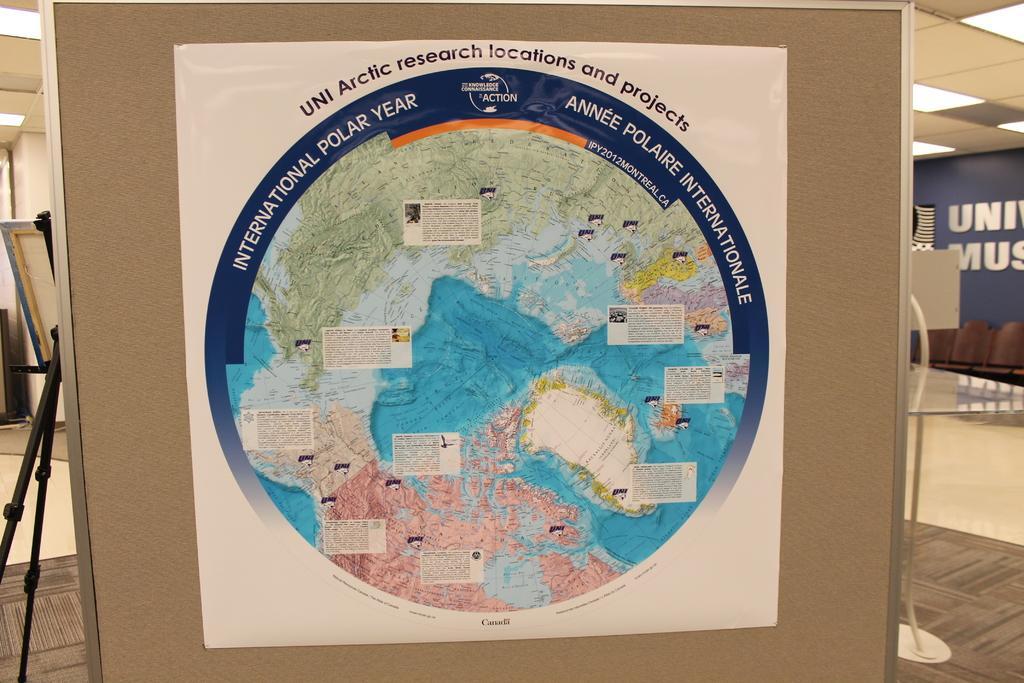Can you describe this image briefly? In this picture we can see a board with a poster on it and in the background we can see a stand on the floor and some objects. 